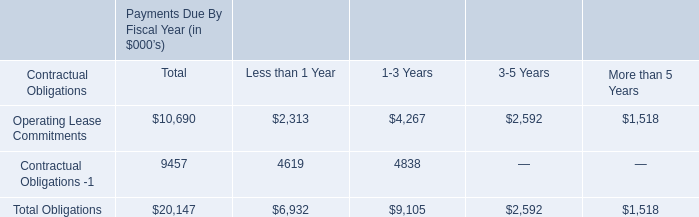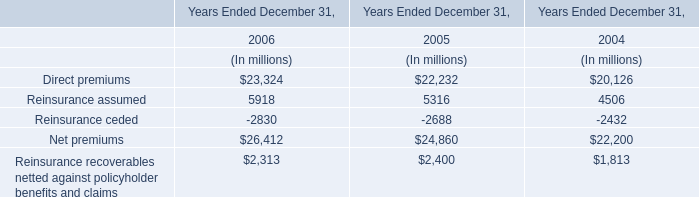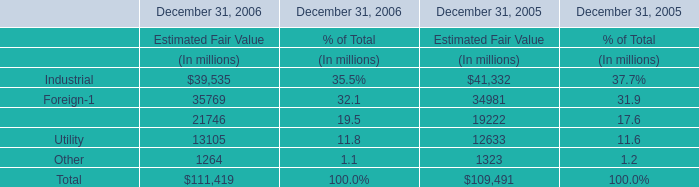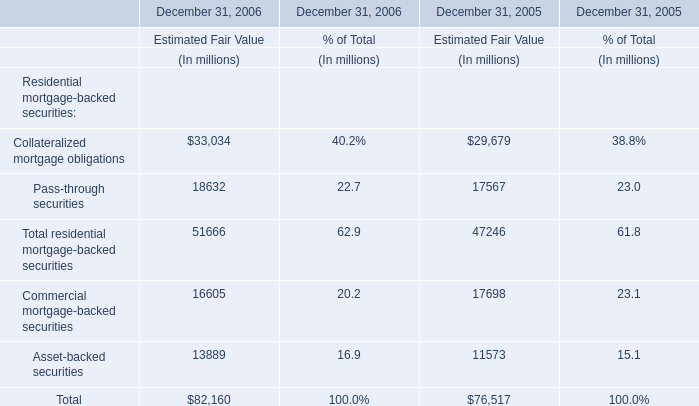What's the increasing rate of Pass-through securities of estimated fair value in 2006? (in %) 
Computations: ((18632 - 17567) / 17567)
Answer: 0.06063. 